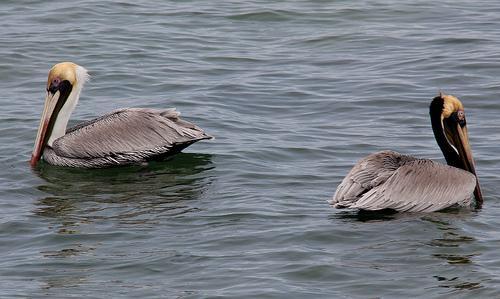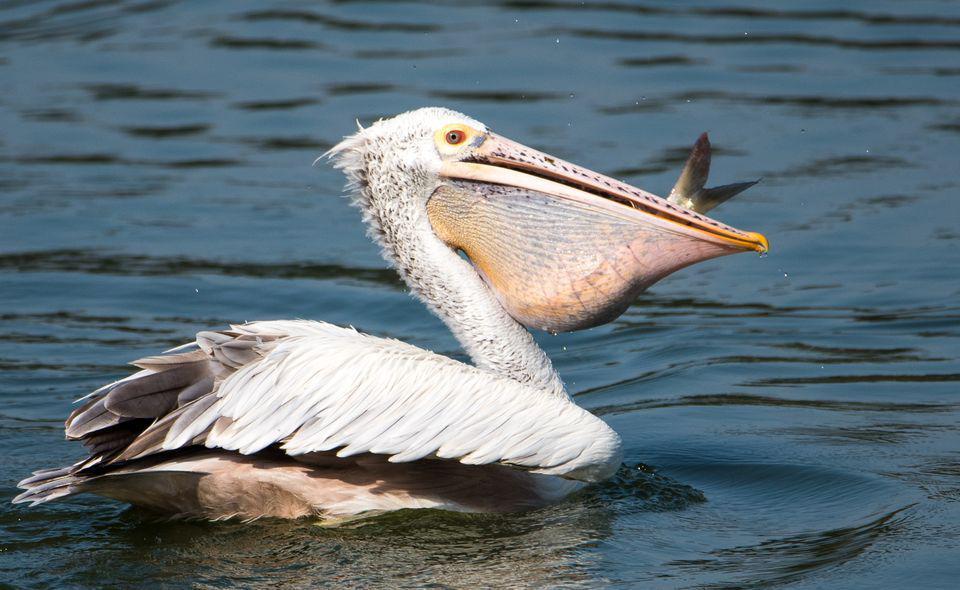The first image is the image on the left, the second image is the image on the right. Evaluate the accuracy of this statement regarding the images: "In one of the image two birds are on a log facing left.". Is it true? Answer yes or no. No. The first image is the image on the left, the second image is the image on the right. Analyze the images presented: Is the assertion "One of the pelicans has a fish in its mouth." valid? Answer yes or no. Yes. 